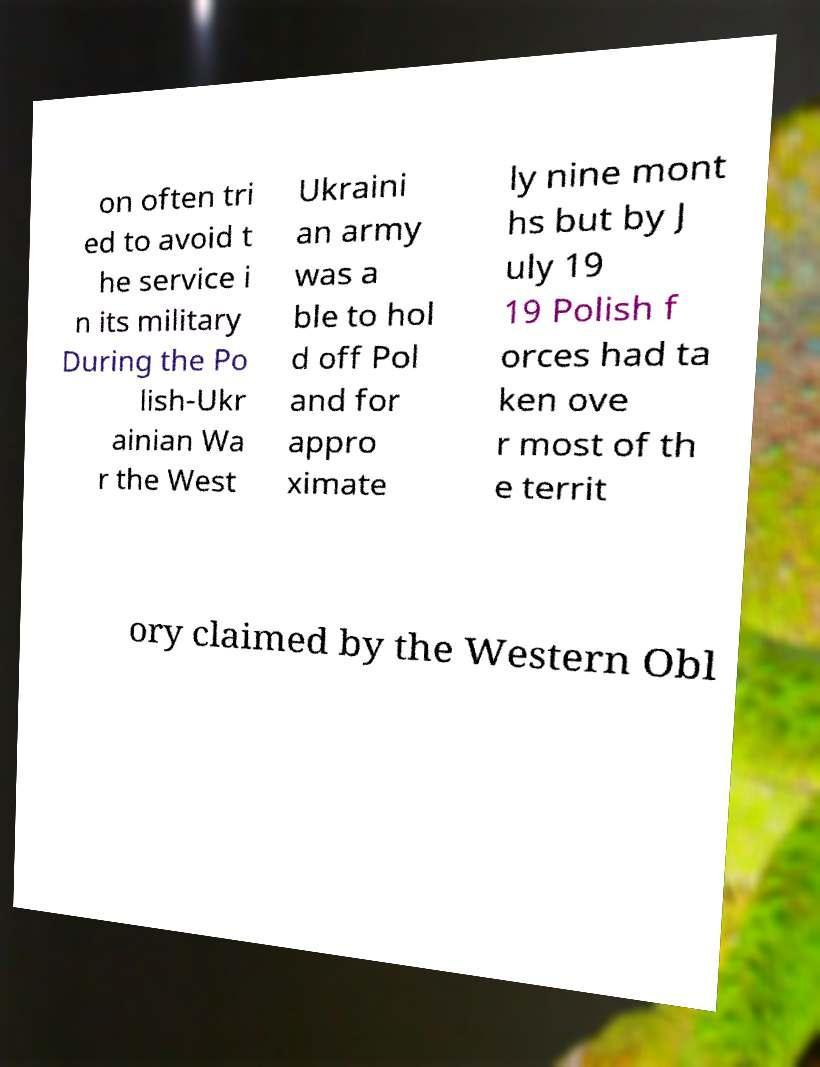There's text embedded in this image that I need extracted. Can you transcribe it verbatim? on often tri ed to avoid t he service i n its military During the Po lish-Ukr ainian Wa r the West Ukraini an army was a ble to hol d off Pol and for appro ximate ly nine mont hs but by J uly 19 19 Polish f orces had ta ken ove r most of th e territ ory claimed by the Western Obl 